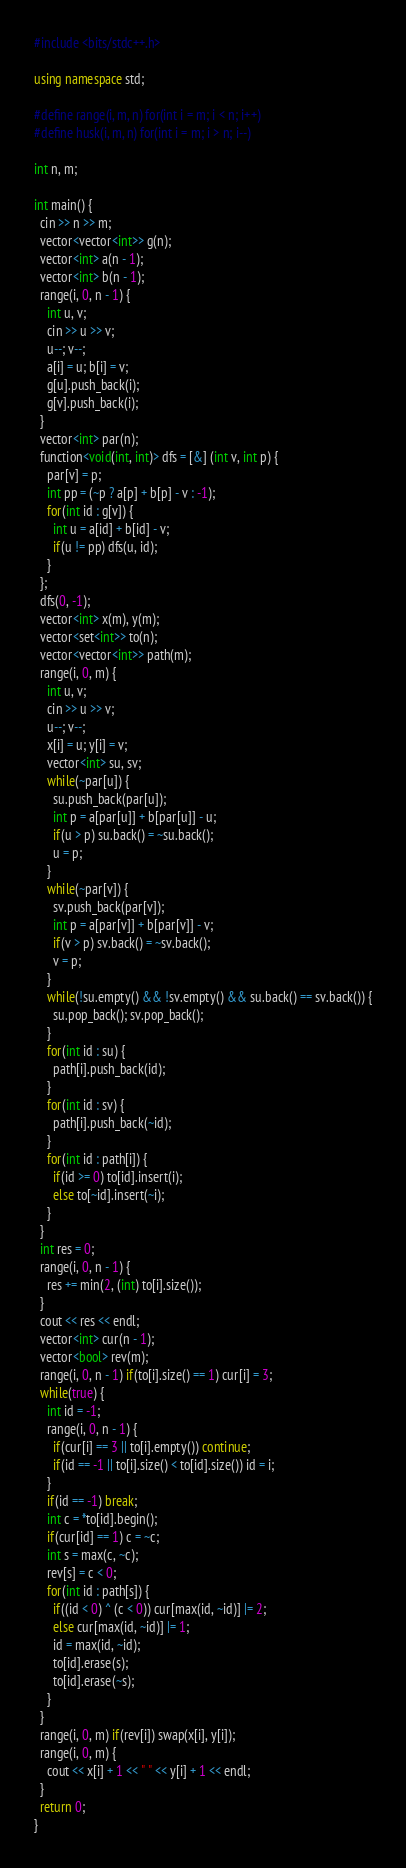<code> <loc_0><loc_0><loc_500><loc_500><_C++_>#include <bits/stdc++.h>

using namespace std;

#define range(i, m, n) for(int i = m; i < n; i++)
#define husk(i, m, n) for(int i = m; i > n; i--)

int n, m;

int main() {
  cin >> n >> m;
  vector<vector<int>> g(n);
  vector<int> a(n - 1);
  vector<int> b(n - 1);
  range(i, 0, n - 1) {
    int u, v;
    cin >> u >> v;
    u--; v--;
    a[i] = u; b[i] = v;
    g[u].push_back(i);
    g[v].push_back(i);
  }
  vector<int> par(n);
  function<void(int, int)> dfs = [&] (int v, int p) {
    par[v] = p;
    int pp = (~p ? a[p] + b[p] - v : -1);
    for(int id : g[v]) {
      int u = a[id] + b[id] - v;
      if(u != pp) dfs(u, id);
    }
  };
  dfs(0, -1);
  vector<int> x(m), y(m);
  vector<set<int>> to(n);
  vector<vector<int>> path(m);
  range(i, 0, m) {
    int u, v;
    cin >> u >> v;
    u--; v--;
    x[i] = u; y[i] = v;
    vector<int> su, sv;
    while(~par[u]) {
      su.push_back(par[u]);
      int p = a[par[u]] + b[par[u]] - u;
      if(u > p) su.back() = ~su.back();
      u = p;
    }
    while(~par[v]) {
      sv.push_back(par[v]);
      int p = a[par[v]] + b[par[v]] - v;
      if(v > p) sv.back() = ~sv.back();
      v = p;
    }
    while(!su.empty() && !sv.empty() && su.back() == sv.back()) {
      su.pop_back(); sv.pop_back();
    }
    for(int id : su) {
      path[i].push_back(id);
    }
    for(int id : sv) {
      path[i].push_back(~id);
    }
    for(int id : path[i]) {
      if(id >= 0) to[id].insert(i);
      else to[~id].insert(~i);
    }
  }
  int res = 0;
  range(i, 0, n - 1) {
    res += min(2, (int) to[i].size());
  }
  cout << res << endl;
  vector<int> cur(n - 1);
  vector<bool> rev(m);
  range(i, 0, n - 1) if(to[i].size() == 1) cur[i] = 3;
  while(true) {
    int id = -1;
    range(i, 0, n - 1) {
      if(cur[i] == 3 || to[i].empty()) continue;
      if(id == -1 || to[i].size() < to[id].size()) id = i;
    }
    if(id == -1) break;
    int c = *to[id].begin();
    if(cur[id] == 1) c = ~c;
    int s = max(c, ~c);
    rev[s] = c < 0;
    for(int id : path[s]) {
      if((id < 0) ^ (c < 0)) cur[max(id, ~id)] |= 2;
      else cur[max(id, ~id)] |= 1;
      id = max(id, ~id);
      to[id].erase(s);
      to[id].erase(~s);
    }
  }
  range(i, 0, m) if(rev[i]) swap(x[i], y[i]);
  range(i, 0, m) {
    cout << x[i] + 1 << " " << y[i] + 1 << endl;
  }
  return 0;
}
</code> 